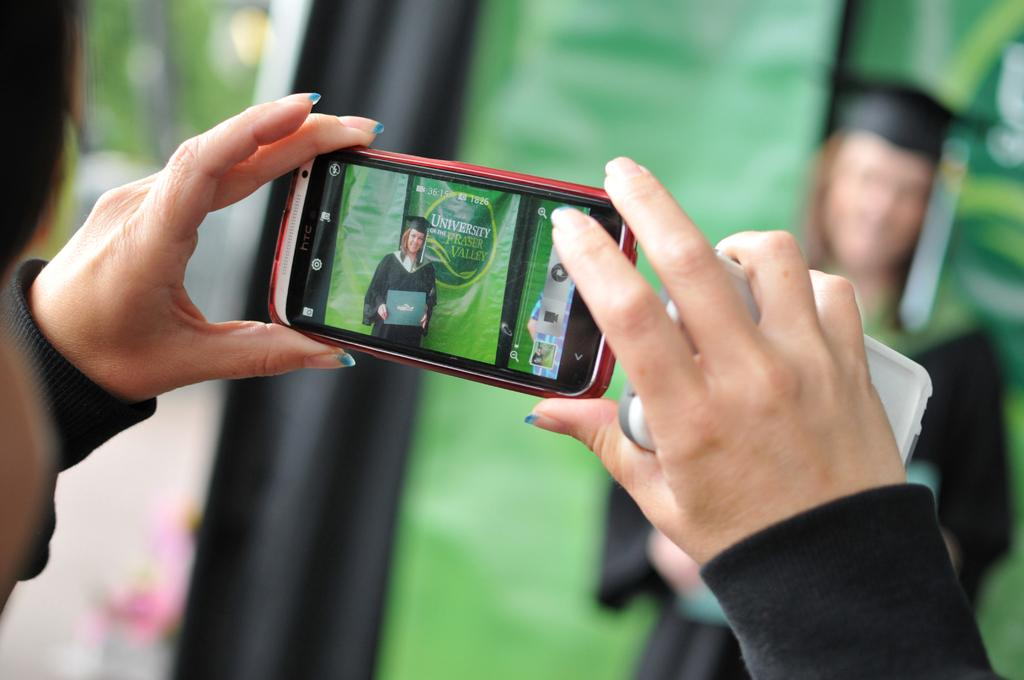<image>
Describe the image concisely. A picture is being taken of a girl in front of the University of the Fraser Valley logo. 